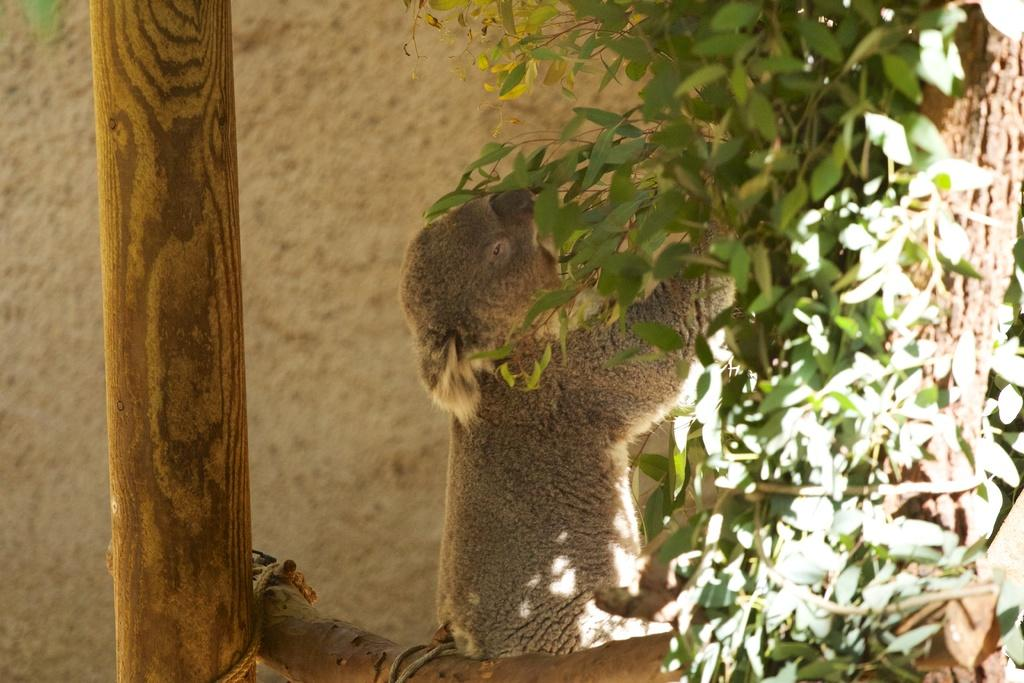What animal is in the image? There is a koala bear in the image. Where is the koala bear located? The koala bear is sitting on a tree branch. What is the koala bear holding? The koala bear is holding leaves. What type of orange is the koala bear eating in the image? There is no orange present in the image; the koala bear is holding leaves. Can you see a locket around the koala bear's neck in the image? There is no locket present in the image; the koala bear is simply holding leaves. 